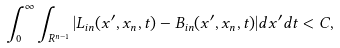Convert formula to latex. <formula><loc_0><loc_0><loc_500><loc_500>\int _ { 0 } ^ { \infty } \int _ { { R } ^ { n - 1 } } | L _ { i n } ( x ^ { \prime } , x _ { n } , t ) - B _ { i n } ( x ^ { \prime } , x _ { n } , t ) | d x ^ { \prime } d t < C ,</formula> 